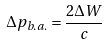<formula> <loc_0><loc_0><loc_500><loc_500>\Delta p _ { b . a . } = \frac { 2 \Delta W } { c }</formula> 